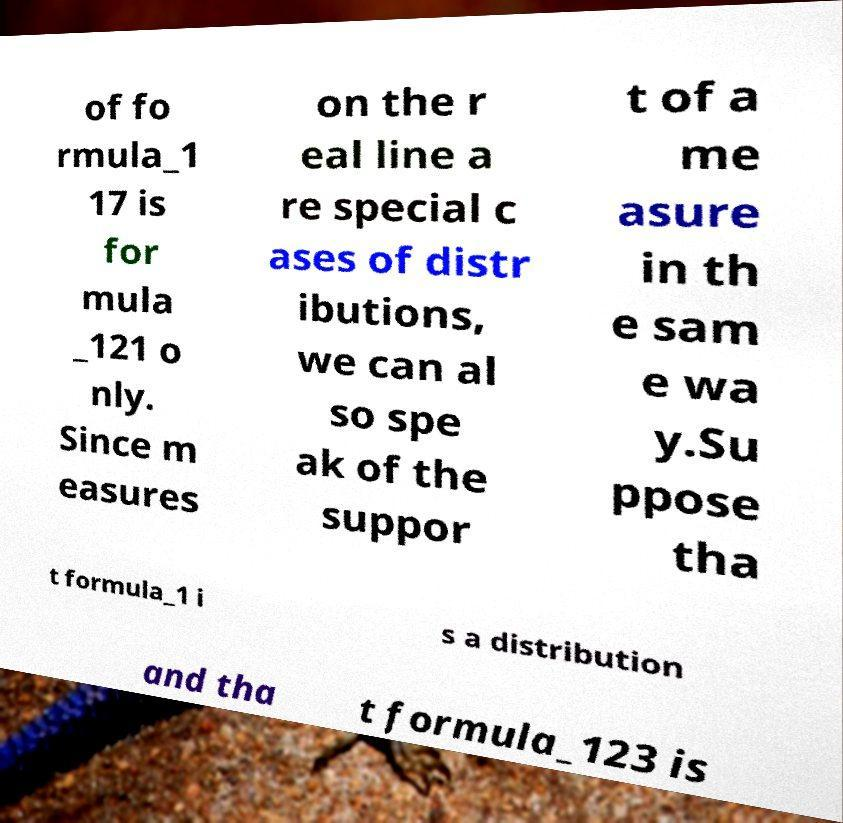I need the written content from this picture converted into text. Can you do that? of fo rmula_1 17 is for mula _121 o nly. Since m easures on the r eal line a re special c ases of distr ibutions, we can al so spe ak of the suppor t of a me asure in th e sam e wa y.Su ppose tha t formula_1 i s a distribution and tha t formula_123 is 